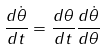Convert formula to latex. <formula><loc_0><loc_0><loc_500><loc_500>\frac { d \dot { \theta } } { d t } = \frac { d \theta } { d t } \frac { d \dot { \theta } } { d \theta }</formula> 